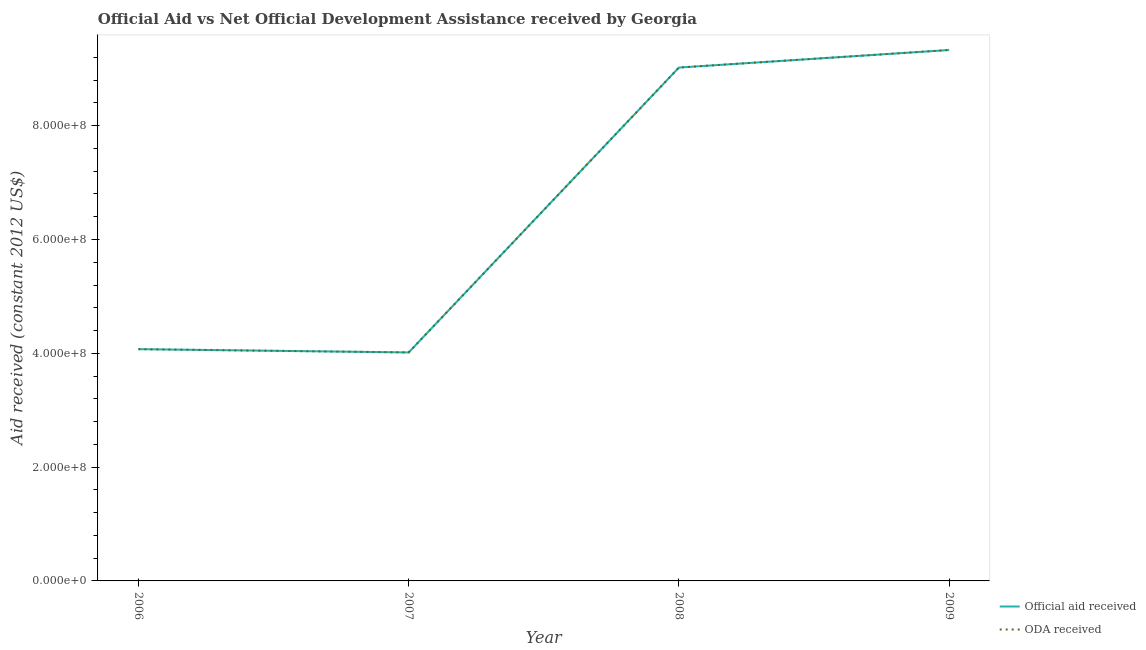How many different coloured lines are there?
Provide a succinct answer. 2. What is the official aid received in 2008?
Provide a short and direct response. 9.02e+08. Across all years, what is the maximum official aid received?
Your response must be concise. 9.33e+08. Across all years, what is the minimum official aid received?
Give a very brief answer. 4.02e+08. In which year was the oda received maximum?
Your answer should be compact. 2009. What is the total oda received in the graph?
Your answer should be compact. 2.64e+09. What is the difference between the official aid received in 2006 and that in 2008?
Your response must be concise. -4.95e+08. What is the difference between the official aid received in 2007 and the oda received in 2008?
Keep it short and to the point. -5.01e+08. What is the average oda received per year?
Your response must be concise. 6.61e+08. In the year 2009, what is the difference between the oda received and official aid received?
Keep it short and to the point. 0. What is the ratio of the oda received in 2006 to that in 2009?
Provide a short and direct response. 0.44. Is the oda received in 2007 less than that in 2009?
Provide a short and direct response. Yes. What is the difference between the highest and the second highest official aid received?
Keep it short and to the point. 3.08e+07. What is the difference between the highest and the lowest official aid received?
Give a very brief answer. 5.31e+08. Is the sum of the oda received in 2007 and 2009 greater than the maximum official aid received across all years?
Provide a short and direct response. Yes. Does the official aid received monotonically increase over the years?
Your response must be concise. No. Is the official aid received strictly less than the oda received over the years?
Provide a short and direct response. No. How many years are there in the graph?
Make the answer very short. 4. What is the difference between two consecutive major ticks on the Y-axis?
Provide a short and direct response. 2.00e+08. Are the values on the major ticks of Y-axis written in scientific E-notation?
Provide a short and direct response. Yes. Does the graph contain any zero values?
Offer a very short reply. No. Does the graph contain grids?
Your answer should be very brief. No. How are the legend labels stacked?
Provide a succinct answer. Vertical. What is the title of the graph?
Offer a terse response. Official Aid vs Net Official Development Assistance received by Georgia . What is the label or title of the Y-axis?
Provide a short and direct response. Aid received (constant 2012 US$). What is the Aid received (constant 2012 US$) of Official aid received in 2006?
Your answer should be very brief. 4.07e+08. What is the Aid received (constant 2012 US$) of ODA received in 2006?
Ensure brevity in your answer.  4.07e+08. What is the Aid received (constant 2012 US$) of Official aid received in 2007?
Ensure brevity in your answer.  4.02e+08. What is the Aid received (constant 2012 US$) of ODA received in 2007?
Offer a very short reply. 4.02e+08. What is the Aid received (constant 2012 US$) of Official aid received in 2008?
Give a very brief answer. 9.02e+08. What is the Aid received (constant 2012 US$) in ODA received in 2008?
Ensure brevity in your answer.  9.02e+08. What is the Aid received (constant 2012 US$) in Official aid received in 2009?
Offer a terse response. 9.33e+08. What is the Aid received (constant 2012 US$) in ODA received in 2009?
Keep it short and to the point. 9.33e+08. Across all years, what is the maximum Aid received (constant 2012 US$) in Official aid received?
Your answer should be compact. 9.33e+08. Across all years, what is the maximum Aid received (constant 2012 US$) in ODA received?
Keep it short and to the point. 9.33e+08. Across all years, what is the minimum Aid received (constant 2012 US$) of Official aid received?
Ensure brevity in your answer.  4.02e+08. Across all years, what is the minimum Aid received (constant 2012 US$) in ODA received?
Your response must be concise. 4.02e+08. What is the total Aid received (constant 2012 US$) of Official aid received in the graph?
Offer a very short reply. 2.64e+09. What is the total Aid received (constant 2012 US$) in ODA received in the graph?
Give a very brief answer. 2.64e+09. What is the difference between the Aid received (constant 2012 US$) of Official aid received in 2006 and that in 2007?
Your answer should be very brief. 5.75e+06. What is the difference between the Aid received (constant 2012 US$) in ODA received in 2006 and that in 2007?
Your answer should be compact. 5.75e+06. What is the difference between the Aid received (constant 2012 US$) in Official aid received in 2006 and that in 2008?
Provide a short and direct response. -4.95e+08. What is the difference between the Aid received (constant 2012 US$) in ODA received in 2006 and that in 2008?
Make the answer very short. -4.95e+08. What is the difference between the Aid received (constant 2012 US$) in Official aid received in 2006 and that in 2009?
Offer a very short reply. -5.26e+08. What is the difference between the Aid received (constant 2012 US$) in ODA received in 2006 and that in 2009?
Ensure brevity in your answer.  -5.26e+08. What is the difference between the Aid received (constant 2012 US$) of Official aid received in 2007 and that in 2008?
Make the answer very short. -5.01e+08. What is the difference between the Aid received (constant 2012 US$) of ODA received in 2007 and that in 2008?
Make the answer very short. -5.01e+08. What is the difference between the Aid received (constant 2012 US$) of Official aid received in 2007 and that in 2009?
Your answer should be very brief. -5.31e+08. What is the difference between the Aid received (constant 2012 US$) in ODA received in 2007 and that in 2009?
Provide a short and direct response. -5.31e+08. What is the difference between the Aid received (constant 2012 US$) in Official aid received in 2008 and that in 2009?
Offer a very short reply. -3.08e+07. What is the difference between the Aid received (constant 2012 US$) in ODA received in 2008 and that in 2009?
Ensure brevity in your answer.  -3.08e+07. What is the difference between the Aid received (constant 2012 US$) in Official aid received in 2006 and the Aid received (constant 2012 US$) in ODA received in 2007?
Make the answer very short. 5.75e+06. What is the difference between the Aid received (constant 2012 US$) of Official aid received in 2006 and the Aid received (constant 2012 US$) of ODA received in 2008?
Your response must be concise. -4.95e+08. What is the difference between the Aid received (constant 2012 US$) of Official aid received in 2006 and the Aid received (constant 2012 US$) of ODA received in 2009?
Your answer should be compact. -5.26e+08. What is the difference between the Aid received (constant 2012 US$) in Official aid received in 2007 and the Aid received (constant 2012 US$) in ODA received in 2008?
Your answer should be very brief. -5.01e+08. What is the difference between the Aid received (constant 2012 US$) of Official aid received in 2007 and the Aid received (constant 2012 US$) of ODA received in 2009?
Provide a short and direct response. -5.31e+08. What is the difference between the Aid received (constant 2012 US$) in Official aid received in 2008 and the Aid received (constant 2012 US$) in ODA received in 2009?
Provide a short and direct response. -3.08e+07. What is the average Aid received (constant 2012 US$) in Official aid received per year?
Provide a short and direct response. 6.61e+08. What is the average Aid received (constant 2012 US$) in ODA received per year?
Make the answer very short. 6.61e+08. In the year 2008, what is the difference between the Aid received (constant 2012 US$) in Official aid received and Aid received (constant 2012 US$) in ODA received?
Provide a short and direct response. 0. What is the ratio of the Aid received (constant 2012 US$) of Official aid received in 2006 to that in 2007?
Ensure brevity in your answer.  1.01. What is the ratio of the Aid received (constant 2012 US$) of ODA received in 2006 to that in 2007?
Offer a terse response. 1.01. What is the ratio of the Aid received (constant 2012 US$) in Official aid received in 2006 to that in 2008?
Provide a short and direct response. 0.45. What is the ratio of the Aid received (constant 2012 US$) in ODA received in 2006 to that in 2008?
Make the answer very short. 0.45. What is the ratio of the Aid received (constant 2012 US$) in Official aid received in 2006 to that in 2009?
Provide a succinct answer. 0.44. What is the ratio of the Aid received (constant 2012 US$) in ODA received in 2006 to that in 2009?
Offer a very short reply. 0.44. What is the ratio of the Aid received (constant 2012 US$) of Official aid received in 2007 to that in 2008?
Give a very brief answer. 0.45. What is the ratio of the Aid received (constant 2012 US$) in ODA received in 2007 to that in 2008?
Provide a succinct answer. 0.45. What is the ratio of the Aid received (constant 2012 US$) of Official aid received in 2007 to that in 2009?
Ensure brevity in your answer.  0.43. What is the ratio of the Aid received (constant 2012 US$) in ODA received in 2007 to that in 2009?
Keep it short and to the point. 0.43. What is the ratio of the Aid received (constant 2012 US$) in Official aid received in 2008 to that in 2009?
Ensure brevity in your answer.  0.97. What is the ratio of the Aid received (constant 2012 US$) of ODA received in 2008 to that in 2009?
Give a very brief answer. 0.97. What is the difference between the highest and the second highest Aid received (constant 2012 US$) of Official aid received?
Offer a terse response. 3.08e+07. What is the difference between the highest and the second highest Aid received (constant 2012 US$) of ODA received?
Provide a succinct answer. 3.08e+07. What is the difference between the highest and the lowest Aid received (constant 2012 US$) of Official aid received?
Provide a short and direct response. 5.31e+08. What is the difference between the highest and the lowest Aid received (constant 2012 US$) in ODA received?
Make the answer very short. 5.31e+08. 